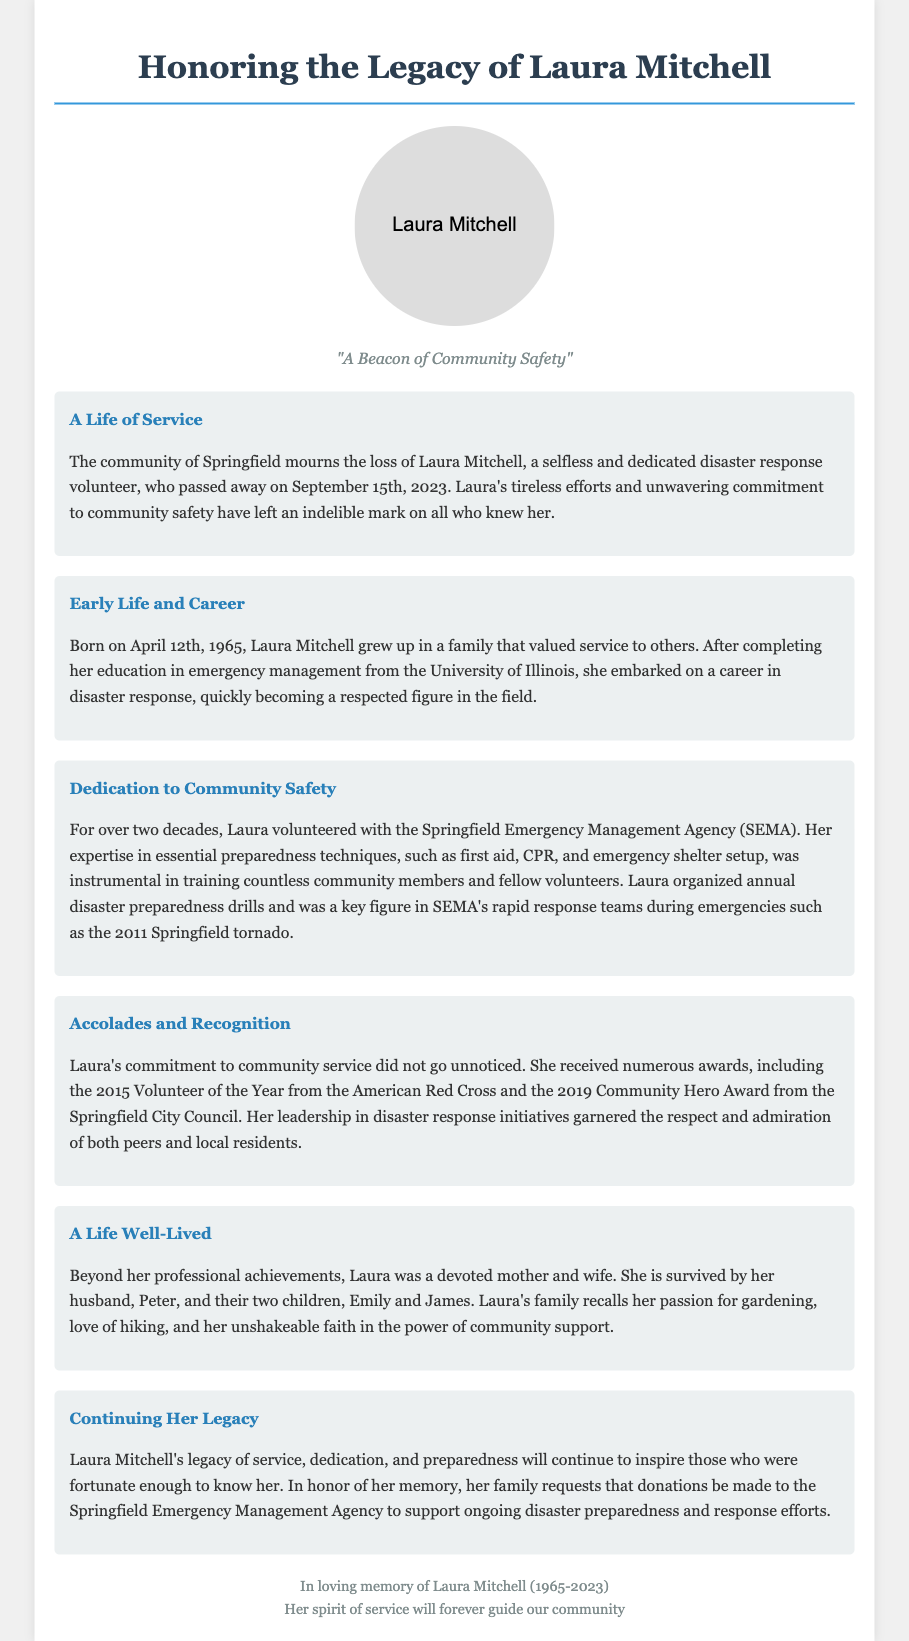What was Laura Mitchell's birth date? The document states Laura Mitchell was born on April 12th, 1965.
Answer: April 12th, 1965 How many years did Laura volunteer with SEMA? The document mentions she volunteered with SEMA for over two decades.
Answer: Over two decades Which award did Laura receive in 2015? The document states she received the Volunteer of the Year from the American Red Cross in 2015.
Answer: Volunteer of the Year What was one of Laura's essential preparedness techniques? The document lists first aid as one of the essential preparedness techniques she taught.
Answer: First aid Who does Laura Mitchell survive? The document mentions she is survived by her husband, Peter, and their two children.
Answer: Husband, Peter, and two children Why are donations requested in Laura's memory? The document indicates donations are requested to support ongoing disaster preparedness and response efforts.
Answer: Support ongoing disaster preparedness and response efforts 